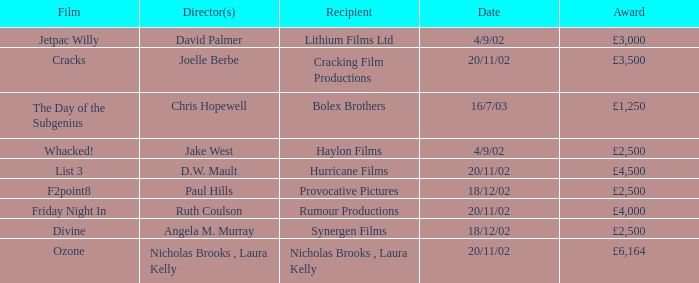On 4/9/02, who received an award worth £3,000? Lithium Films Ltd. Could you parse the entire table as a dict? {'header': ['Film', 'Director(s)', 'Recipient', 'Date', 'Award'], 'rows': [['Jetpac Willy', 'David Palmer', 'Lithium Films Ltd', '4/9/02', '£3,000'], ['Cracks', 'Joelle Berbe', 'Cracking Film Productions', '20/11/02', '£3,500'], ['The Day of the Subgenius', 'Chris Hopewell', 'Bolex Brothers', '16/7/03', '£1,250'], ['Whacked!', 'Jake West', 'Haylon Films', '4/9/02', '£2,500'], ['List 3', 'D.W. Mault', 'Hurricane Films', '20/11/02', '£4,500'], ['F2point8', 'Paul Hills', 'Provocative Pictures', '18/12/02', '£2,500'], ['Friday Night In', 'Ruth Coulson', 'Rumour Productions', '20/11/02', '£4,000'], ['Divine', 'Angela M. Murray', 'Synergen Films', '18/12/02', '£2,500'], ['Ozone', 'Nicholas Brooks , Laura Kelly', 'Nicholas Brooks , Laura Kelly', '20/11/02', '£6,164']]} 